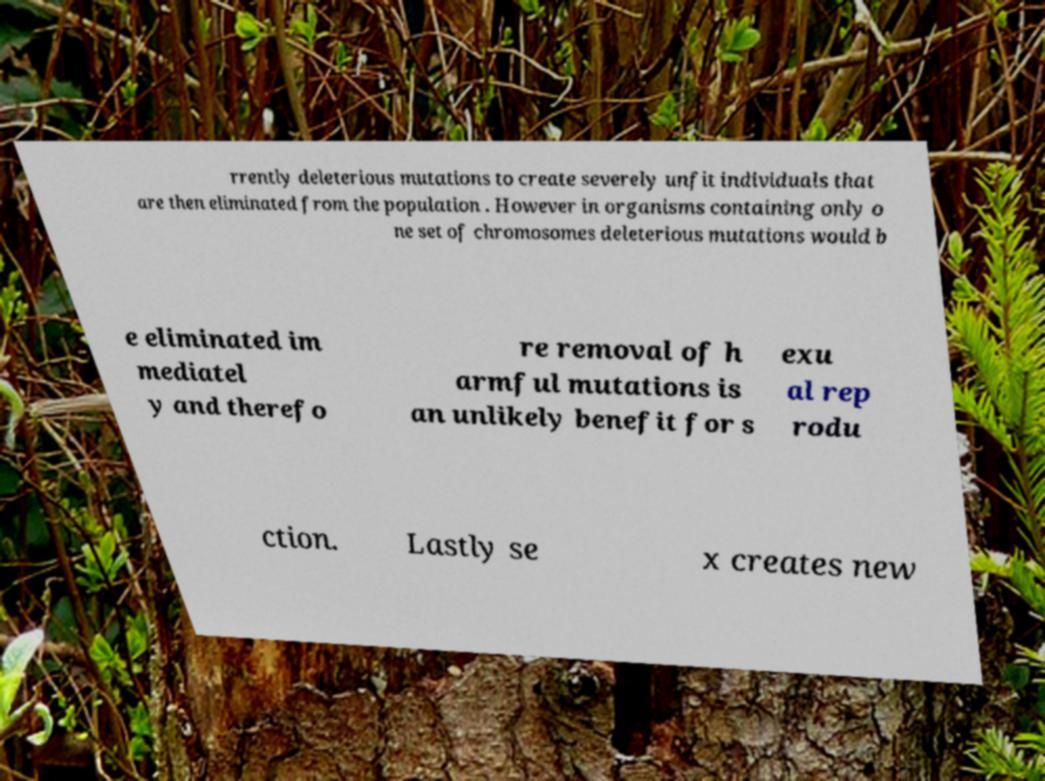I need the written content from this picture converted into text. Can you do that? rrently deleterious mutations to create severely unfit individuals that are then eliminated from the population . However in organisms containing only o ne set of chromosomes deleterious mutations would b e eliminated im mediatel y and therefo re removal of h armful mutations is an unlikely benefit for s exu al rep rodu ction. Lastly se x creates new 